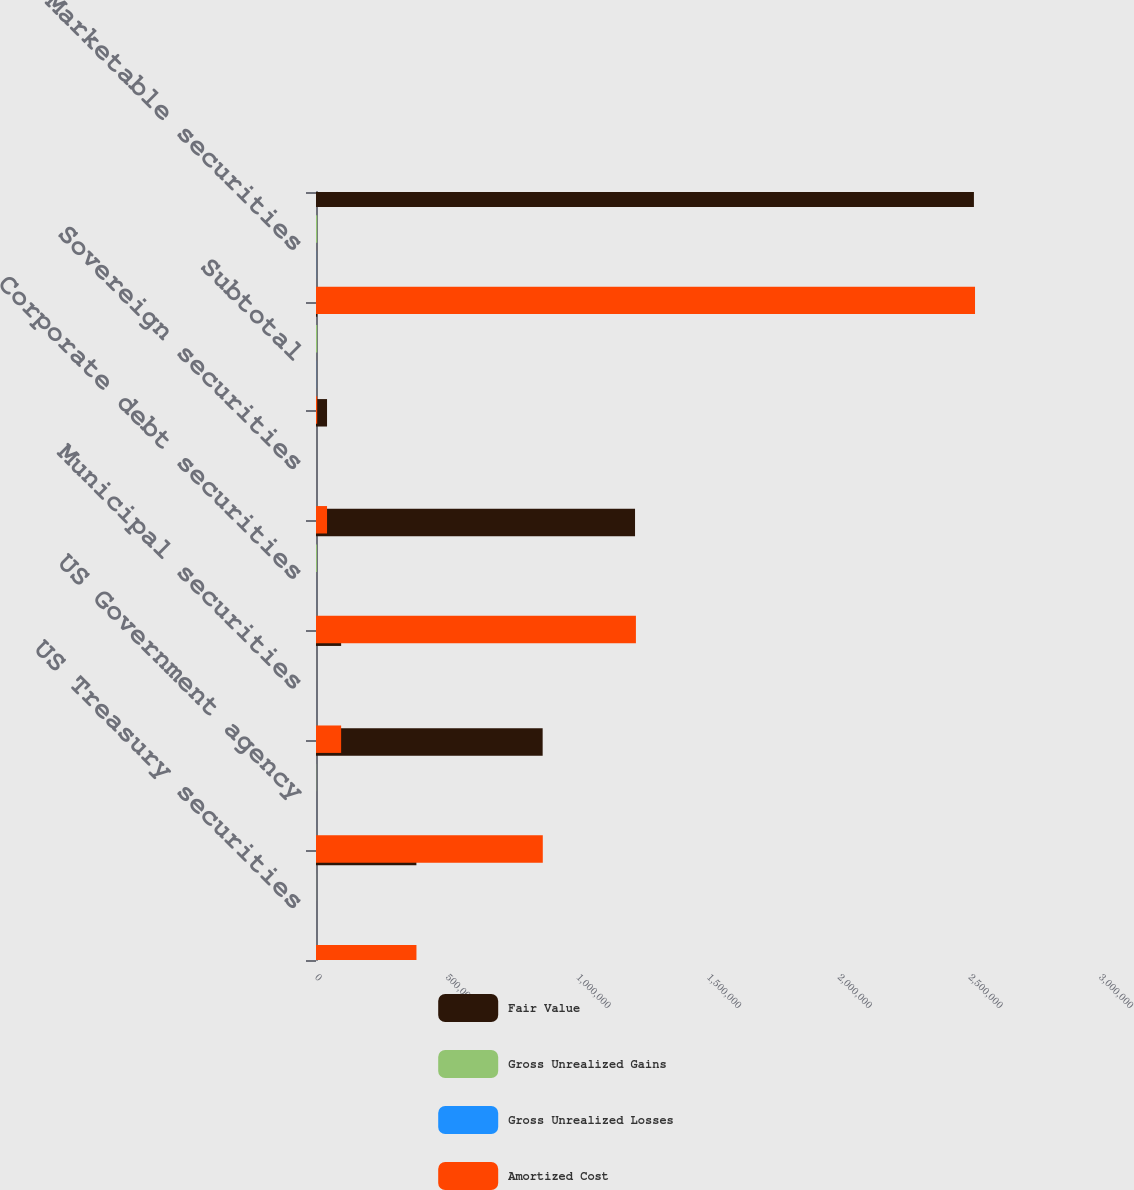Convert chart to OTSL. <chart><loc_0><loc_0><loc_500><loc_500><stacked_bar_chart><ecel><fcel>US Treasury securities<fcel>US Government agency<fcel>Municipal securities<fcel>Corporate debt securities<fcel>Sovereign securities<fcel>Subtotal<fcel>Marketable securities<nl><fcel>Fair Value<fcel>384165<fcel>867309<fcel>96198<fcel>1.22079e+06<fcel>42227<fcel>4603<fcel>2.51757e+06<nl><fcel>Gross Unrealized Gains<fcel>287<fcel>651<fcel>93<fcel>3526<fcel>46<fcel>4603<fcel>4603<nl><fcel>Gross Unrealized Losses<fcel>52<fcel>117<fcel>75<fcel>152<fcel>9<fcel>405<fcel>397<nl><fcel>Amortized Cost<fcel>384400<fcel>867843<fcel>96216<fcel>1.22417e+06<fcel>42264<fcel>4603<fcel>2.52178e+06<nl></chart> 